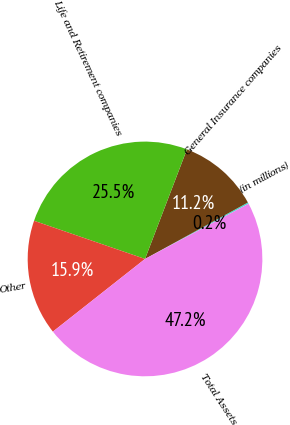Convert chart to OTSL. <chart><loc_0><loc_0><loc_500><loc_500><pie_chart><fcel>(in millions)<fcel>General Insurance companies<fcel>Life and Retirement companies<fcel>Other<fcel>Total Assets<nl><fcel>0.19%<fcel>11.2%<fcel>25.54%<fcel>15.9%<fcel>47.17%<nl></chart> 